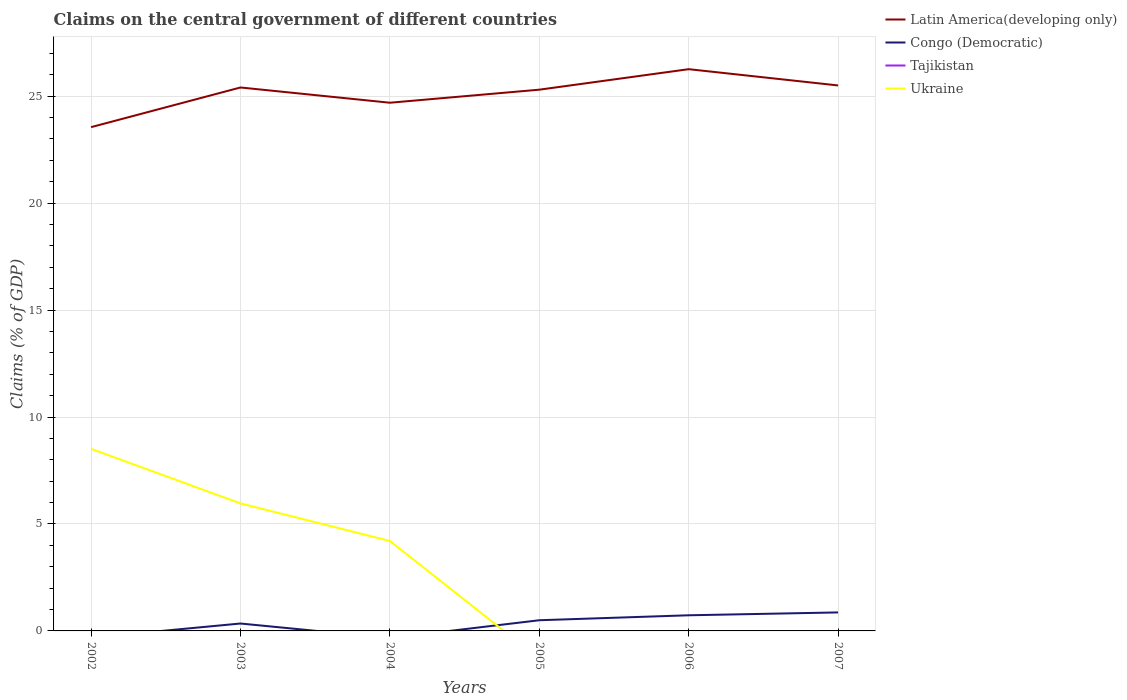What is the total percentage of GDP claimed on the central government in Latin America(developing only) in the graph?
Ensure brevity in your answer.  -0.81. What is the difference between the highest and the second highest percentage of GDP claimed on the central government in Latin America(developing only)?
Offer a terse response. 2.71. Is the percentage of GDP claimed on the central government in Tajikistan strictly greater than the percentage of GDP claimed on the central government in Latin America(developing only) over the years?
Ensure brevity in your answer.  Yes. How many years are there in the graph?
Your answer should be compact. 6. What is the difference between two consecutive major ticks on the Y-axis?
Your response must be concise. 5. How are the legend labels stacked?
Your answer should be compact. Vertical. What is the title of the graph?
Your answer should be compact. Claims on the central government of different countries. Does "Mongolia" appear as one of the legend labels in the graph?
Your response must be concise. No. What is the label or title of the X-axis?
Provide a short and direct response. Years. What is the label or title of the Y-axis?
Your answer should be compact. Claims (% of GDP). What is the Claims (% of GDP) of Latin America(developing only) in 2002?
Ensure brevity in your answer.  23.55. What is the Claims (% of GDP) in Tajikistan in 2002?
Your answer should be very brief. 0. What is the Claims (% of GDP) in Ukraine in 2002?
Provide a short and direct response. 8.51. What is the Claims (% of GDP) in Latin America(developing only) in 2003?
Ensure brevity in your answer.  25.41. What is the Claims (% of GDP) in Congo (Democratic) in 2003?
Give a very brief answer. 0.35. What is the Claims (% of GDP) in Ukraine in 2003?
Offer a terse response. 5.96. What is the Claims (% of GDP) in Latin America(developing only) in 2004?
Give a very brief answer. 24.7. What is the Claims (% of GDP) in Congo (Democratic) in 2004?
Your answer should be very brief. 0. What is the Claims (% of GDP) of Ukraine in 2004?
Keep it short and to the point. 4.21. What is the Claims (% of GDP) in Latin America(developing only) in 2005?
Make the answer very short. 25.31. What is the Claims (% of GDP) of Congo (Democratic) in 2005?
Your answer should be compact. 0.5. What is the Claims (% of GDP) of Tajikistan in 2005?
Offer a terse response. 0. What is the Claims (% of GDP) in Latin America(developing only) in 2006?
Offer a very short reply. 26.26. What is the Claims (% of GDP) of Congo (Democratic) in 2006?
Provide a succinct answer. 0.73. What is the Claims (% of GDP) in Latin America(developing only) in 2007?
Keep it short and to the point. 25.5. What is the Claims (% of GDP) in Congo (Democratic) in 2007?
Make the answer very short. 0.87. Across all years, what is the maximum Claims (% of GDP) of Latin America(developing only)?
Your answer should be very brief. 26.26. Across all years, what is the maximum Claims (% of GDP) in Congo (Democratic)?
Ensure brevity in your answer.  0.87. Across all years, what is the maximum Claims (% of GDP) of Ukraine?
Offer a terse response. 8.51. Across all years, what is the minimum Claims (% of GDP) of Latin America(developing only)?
Your answer should be very brief. 23.55. Across all years, what is the minimum Claims (% of GDP) of Ukraine?
Your response must be concise. 0. What is the total Claims (% of GDP) in Latin America(developing only) in the graph?
Keep it short and to the point. 150.73. What is the total Claims (% of GDP) in Congo (Democratic) in the graph?
Ensure brevity in your answer.  2.44. What is the total Claims (% of GDP) in Tajikistan in the graph?
Provide a succinct answer. 0. What is the total Claims (% of GDP) of Ukraine in the graph?
Your response must be concise. 18.68. What is the difference between the Claims (% of GDP) in Latin America(developing only) in 2002 and that in 2003?
Your answer should be very brief. -1.85. What is the difference between the Claims (% of GDP) of Ukraine in 2002 and that in 2003?
Keep it short and to the point. 2.55. What is the difference between the Claims (% of GDP) of Latin America(developing only) in 2002 and that in 2004?
Keep it short and to the point. -1.14. What is the difference between the Claims (% of GDP) of Ukraine in 2002 and that in 2004?
Your response must be concise. 4.31. What is the difference between the Claims (% of GDP) in Latin America(developing only) in 2002 and that in 2005?
Keep it short and to the point. -1.75. What is the difference between the Claims (% of GDP) in Latin America(developing only) in 2002 and that in 2006?
Provide a succinct answer. -2.71. What is the difference between the Claims (% of GDP) of Latin America(developing only) in 2002 and that in 2007?
Offer a terse response. -1.95. What is the difference between the Claims (% of GDP) of Latin America(developing only) in 2003 and that in 2004?
Give a very brief answer. 0.71. What is the difference between the Claims (% of GDP) of Ukraine in 2003 and that in 2004?
Your response must be concise. 1.76. What is the difference between the Claims (% of GDP) in Latin America(developing only) in 2003 and that in 2005?
Your answer should be very brief. 0.1. What is the difference between the Claims (% of GDP) in Congo (Democratic) in 2003 and that in 2005?
Offer a very short reply. -0.15. What is the difference between the Claims (% of GDP) in Latin America(developing only) in 2003 and that in 2006?
Offer a very short reply. -0.86. What is the difference between the Claims (% of GDP) of Congo (Democratic) in 2003 and that in 2006?
Provide a succinct answer. -0.38. What is the difference between the Claims (% of GDP) of Latin America(developing only) in 2003 and that in 2007?
Offer a very short reply. -0.09. What is the difference between the Claims (% of GDP) of Congo (Democratic) in 2003 and that in 2007?
Your answer should be compact. -0.52. What is the difference between the Claims (% of GDP) of Latin America(developing only) in 2004 and that in 2005?
Offer a very short reply. -0.61. What is the difference between the Claims (% of GDP) in Latin America(developing only) in 2004 and that in 2006?
Offer a very short reply. -1.57. What is the difference between the Claims (% of GDP) of Latin America(developing only) in 2004 and that in 2007?
Offer a very short reply. -0.81. What is the difference between the Claims (% of GDP) of Latin America(developing only) in 2005 and that in 2006?
Make the answer very short. -0.96. What is the difference between the Claims (% of GDP) of Congo (Democratic) in 2005 and that in 2006?
Your response must be concise. -0.23. What is the difference between the Claims (% of GDP) in Latin America(developing only) in 2005 and that in 2007?
Keep it short and to the point. -0.2. What is the difference between the Claims (% of GDP) of Congo (Democratic) in 2005 and that in 2007?
Make the answer very short. -0.37. What is the difference between the Claims (% of GDP) in Latin America(developing only) in 2006 and that in 2007?
Offer a very short reply. 0.76. What is the difference between the Claims (% of GDP) of Congo (Democratic) in 2006 and that in 2007?
Offer a terse response. -0.13. What is the difference between the Claims (% of GDP) in Latin America(developing only) in 2002 and the Claims (% of GDP) in Congo (Democratic) in 2003?
Ensure brevity in your answer.  23.21. What is the difference between the Claims (% of GDP) of Latin America(developing only) in 2002 and the Claims (% of GDP) of Ukraine in 2003?
Your answer should be compact. 17.59. What is the difference between the Claims (% of GDP) of Latin America(developing only) in 2002 and the Claims (% of GDP) of Ukraine in 2004?
Your response must be concise. 19.35. What is the difference between the Claims (% of GDP) of Latin America(developing only) in 2002 and the Claims (% of GDP) of Congo (Democratic) in 2005?
Ensure brevity in your answer.  23.05. What is the difference between the Claims (% of GDP) of Latin America(developing only) in 2002 and the Claims (% of GDP) of Congo (Democratic) in 2006?
Provide a short and direct response. 22.82. What is the difference between the Claims (% of GDP) in Latin America(developing only) in 2002 and the Claims (% of GDP) in Congo (Democratic) in 2007?
Provide a succinct answer. 22.69. What is the difference between the Claims (% of GDP) in Latin America(developing only) in 2003 and the Claims (% of GDP) in Ukraine in 2004?
Provide a short and direct response. 21.2. What is the difference between the Claims (% of GDP) of Congo (Democratic) in 2003 and the Claims (% of GDP) of Ukraine in 2004?
Offer a very short reply. -3.86. What is the difference between the Claims (% of GDP) of Latin America(developing only) in 2003 and the Claims (% of GDP) of Congo (Democratic) in 2005?
Offer a terse response. 24.91. What is the difference between the Claims (% of GDP) of Latin America(developing only) in 2003 and the Claims (% of GDP) of Congo (Democratic) in 2006?
Ensure brevity in your answer.  24.68. What is the difference between the Claims (% of GDP) of Latin America(developing only) in 2003 and the Claims (% of GDP) of Congo (Democratic) in 2007?
Your answer should be very brief. 24.54. What is the difference between the Claims (% of GDP) of Latin America(developing only) in 2004 and the Claims (% of GDP) of Congo (Democratic) in 2005?
Provide a succinct answer. 24.2. What is the difference between the Claims (% of GDP) in Latin America(developing only) in 2004 and the Claims (% of GDP) in Congo (Democratic) in 2006?
Make the answer very short. 23.96. What is the difference between the Claims (% of GDP) of Latin America(developing only) in 2004 and the Claims (% of GDP) of Congo (Democratic) in 2007?
Your answer should be very brief. 23.83. What is the difference between the Claims (% of GDP) in Latin America(developing only) in 2005 and the Claims (% of GDP) in Congo (Democratic) in 2006?
Keep it short and to the point. 24.57. What is the difference between the Claims (% of GDP) of Latin America(developing only) in 2005 and the Claims (% of GDP) of Congo (Democratic) in 2007?
Offer a very short reply. 24.44. What is the difference between the Claims (% of GDP) in Latin America(developing only) in 2006 and the Claims (% of GDP) in Congo (Democratic) in 2007?
Your answer should be very brief. 25.4. What is the average Claims (% of GDP) in Latin America(developing only) per year?
Offer a terse response. 25.12. What is the average Claims (% of GDP) of Congo (Democratic) per year?
Ensure brevity in your answer.  0.41. What is the average Claims (% of GDP) in Tajikistan per year?
Keep it short and to the point. 0. What is the average Claims (% of GDP) in Ukraine per year?
Your answer should be very brief. 3.11. In the year 2002, what is the difference between the Claims (% of GDP) in Latin America(developing only) and Claims (% of GDP) in Ukraine?
Provide a short and direct response. 15.04. In the year 2003, what is the difference between the Claims (% of GDP) in Latin America(developing only) and Claims (% of GDP) in Congo (Democratic)?
Offer a very short reply. 25.06. In the year 2003, what is the difference between the Claims (% of GDP) in Latin America(developing only) and Claims (% of GDP) in Ukraine?
Your response must be concise. 19.45. In the year 2003, what is the difference between the Claims (% of GDP) of Congo (Democratic) and Claims (% of GDP) of Ukraine?
Make the answer very short. -5.62. In the year 2004, what is the difference between the Claims (% of GDP) of Latin America(developing only) and Claims (% of GDP) of Ukraine?
Ensure brevity in your answer.  20.49. In the year 2005, what is the difference between the Claims (% of GDP) in Latin America(developing only) and Claims (% of GDP) in Congo (Democratic)?
Offer a very short reply. 24.81. In the year 2006, what is the difference between the Claims (% of GDP) in Latin America(developing only) and Claims (% of GDP) in Congo (Democratic)?
Ensure brevity in your answer.  25.53. In the year 2007, what is the difference between the Claims (% of GDP) in Latin America(developing only) and Claims (% of GDP) in Congo (Democratic)?
Give a very brief answer. 24.64. What is the ratio of the Claims (% of GDP) of Latin America(developing only) in 2002 to that in 2003?
Keep it short and to the point. 0.93. What is the ratio of the Claims (% of GDP) in Ukraine in 2002 to that in 2003?
Offer a terse response. 1.43. What is the ratio of the Claims (% of GDP) in Latin America(developing only) in 2002 to that in 2004?
Your response must be concise. 0.95. What is the ratio of the Claims (% of GDP) of Ukraine in 2002 to that in 2004?
Offer a terse response. 2.02. What is the ratio of the Claims (% of GDP) in Latin America(developing only) in 2002 to that in 2005?
Offer a terse response. 0.93. What is the ratio of the Claims (% of GDP) in Latin America(developing only) in 2002 to that in 2006?
Offer a terse response. 0.9. What is the ratio of the Claims (% of GDP) of Latin America(developing only) in 2002 to that in 2007?
Ensure brevity in your answer.  0.92. What is the ratio of the Claims (% of GDP) of Latin America(developing only) in 2003 to that in 2004?
Provide a succinct answer. 1.03. What is the ratio of the Claims (% of GDP) in Ukraine in 2003 to that in 2004?
Give a very brief answer. 1.42. What is the ratio of the Claims (% of GDP) of Latin America(developing only) in 2003 to that in 2005?
Give a very brief answer. 1. What is the ratio of the Claims (% of GDP) in Congo (Democratic) in 2003 to that in 2005?
Your answer should be compact. 0.69. What is the ratio of the Claims (% of GDP) of Latin America(developing only) in 2003 to that in 2006?
Offer a very short reply. 0.97. What is the ratio of the Claims (% of GDP) of Congo (Democratic) in 2003 to that in 2006?
Give a very brief answer. 0.47. What is the ratio of the Claims (% of GDP) in Latin America(developing only) in 2003 to that in 2007?
Ensure brevity in your answer.  1. What is the ratio of the Claims (% of GDP) in Congo (Democratic) in 2003 to that in 2007?
Your response must be concise. 0.4. What is the ratio of the Claims (% of GDP) in Latin America(developing only) in 2004 to that in 2005?
Your answer should be very brief. 0.98. What is the ratio of the Claims (% of GDP) of Latin America(developing only) in 2004 to that in 2006?
Offer a terse response. 0.94. What is the ratio of the Claims (% of GDP) of Latin America(developing only) in 2004 to that in 2007?
Offer a terse response. 0.97. What is the ratio of the Claims (% of GDP) in Latin America(developing only) in 2005 to that in 2006?
Your answer should be compact. 0.96. What is the ratio of the Claims (% of GDP) of Congo (Democratic) in 2005 to that in 2006?
Offer a very short reply. 0.68. What is the ratio of the Claims (% of GDP) in Latin America(developing only) in 2005 to that in 2007?
Make the answer very short. 0.99. What is the ratio of the Claims (% of GDP) of Congo (Democratic) in 2005 to that in 2007?
Your answer should be compact. 0.58. What is the ratio of the Claims (% of GDP) in Latin America(developing only) in 2006 to that in 2007?
Give a very brief answer. 1.03. What is the ratio of the Claims (% of GDP) in Congo (Democratic) in 2006 to that in 2007?
Your answer should be very brief. 0.84. What is the difference between the highest and the second highest Claims (% of GDP) of Latin America(developing only)?
Keep it short and to the point. 0.76. What is the difference between the highest and the second highest Claims (% of GDP) of Congo (Democratic)?
Provide a succinct answer. 0.13. What is the difference between the highest and the second highest Claims (% of GDP) in Ukraine?
Your response must be concise. 2.55. What is the difference between the highest and the lowest Claims (% of GDP) in Latin America(developing only)?
Provide a short and direct response. 2.71. What is the difference between the highest and the lowest Claims (% of GDP) in Congo (Democratic)?
Your response must be concise. 0.87. What is the difference between the highest and the lowest Claims (% of GDP) in Ukraine?
Keep it short and to the point. 8.51. 